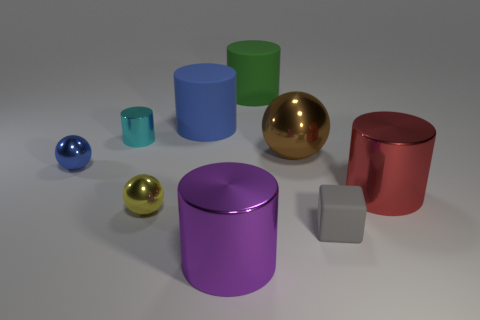Subtract all large green matte cylinders. How many cylinders are left? 4 Subtract all cyan cylinders. How many cylinders are left? 4 Subtract 1 cylinders. How many cylinders are left? 4 Subtract all gray cylinders. Subtract all gray cubes. How many cylinders are left? 5 Add 1 tiny metal things. How many objects exist? 10 Subtract all spheres. How many objects are left? 6 Add 4 large purple objects. How many large purple objects are left? 5 Add 6 yellow spheres. How many yellow spheres exist? 7 Subtract 0 brown cylinders. How many objects are left? 9 Subtract all small cyan metallic cylinders. Subtract all blue things. How many objects are left? 6 